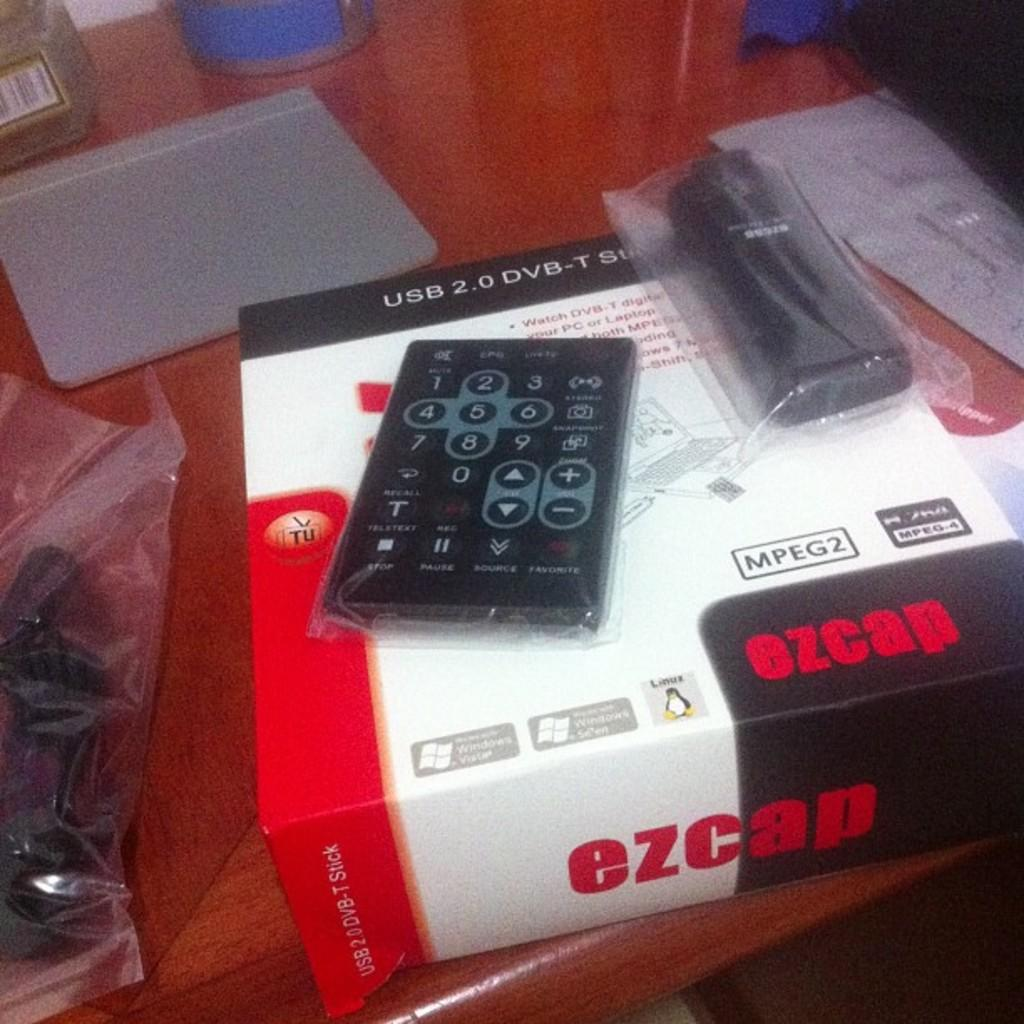<image>
Create a compact narrative representing the image presented. Controller on top of a white box that says EZCAP. 